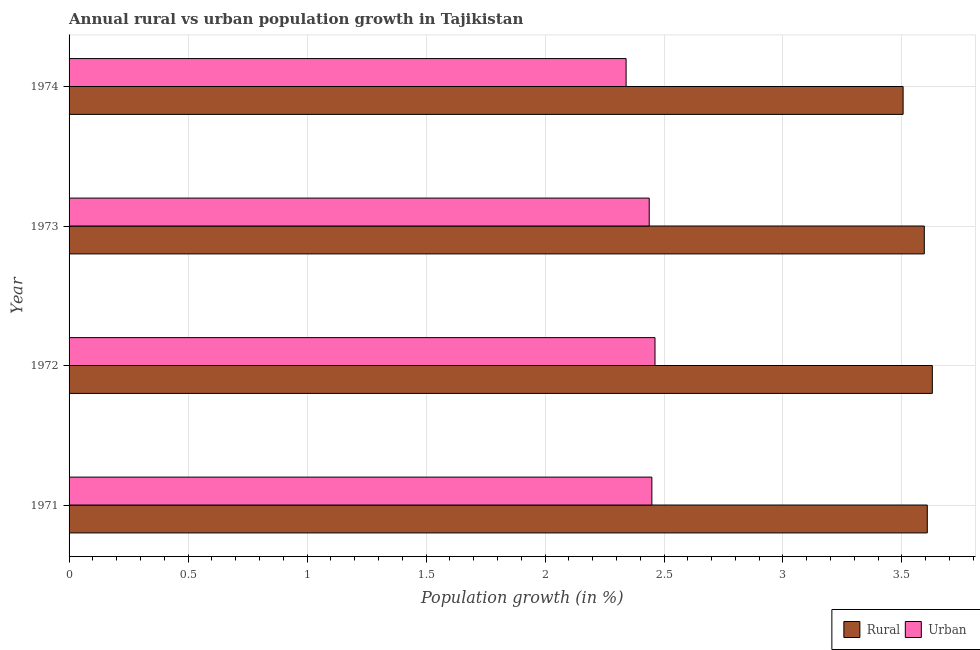How many groups of bars are there?
Offer a very short reply. 4. Are the number of bars per tick equal to the number of legend labels?
Your response must be concise. Yes. Are the number of bars on each tick of the Y-axis equal?
Keep it short and to the point. Yes. What is the label of the 2nd group of bars from the top?
Keep it short and to the point. 1973. In how many cases, is the number of bars for a given year not equal to the number of legend labels?
Your answer should be very brief. 0. What is the urban population growth in 1973?
Offer a terse response. 2.44. Across all years, what is the maximum rural population growth?
Make the answer very short. 3.63. Across all years, what is the minimum urban population growth?
Provide a succinct answer. 2.34. In which year was the rural population growth maximum?
Your answer should be compact. 1972. In which year was the rural population growth minimum?
Provide a short and direct response. 1974. What is the total rural population growth in the graph?
Your answer should be compact. 14.33. What is the difference between the urban population growth in 1972 and that in 1973?
Make the answer very short. 0.02. What is the difference between the rural population growth in 1974 and the urban population growth in 1972?
Provide a succinct answer. 1.04. What is the average rural population growth per year?
Your response must be concise. 3.58. In the year 1971, what is the difference between the urban population growth and rural population growth?
Ensure brevity in your answer.  -1.16. In how many years, is the rural population growth greater than 0.5 %?
Ensure brevity in your answer.  4. What is the ratio of the rural population growth in 1972 to that in 1974?
Provide a succinct answer. 1.03. Is the difference between the rural population growth in 1973 and 1974 greater than the difference between the urban population growth in 1973 and 1974?
Provide a succinct answer. No. What is the difference between the highest and the second highest rural population growth?
Your answer should be compact. 0.02. What is the difference between the highest and the lowest urban population growth?
Your answer should be very brief. 0.12. Is the sum of the rural population growth in 1972 and 1973 greater than the maximum urban population growth across all years?
Provide a short and direct response. Yes. What does the 1st bar from the top in 1971 represents?
Offer a terse response. Urban . What does the 1st bar from the bottom in 1972 represents?
Your response must be concise. Rural. How many bars are there?
Provide a short and direct response. 8. Are all the bars in the graph horizontal?
Your answer should be compact. Yes. What is the difference between two consecutive major ticks on the X-axis?
Offer a terse response. 0.5. Does the graph contain any zero values?
Offer a terse response. No. Does the graph contain grids?
Provide a short and direct response. Yes. Where does the legend appear in the graph?
Keep it short and to the point. Bottom right. What is the title of the graph?
Your answer should be compact. Annual rural vs urban population growth in Tajikistan. What is the label or title of the X-axis?
Your answer should be compact. Population growth (in %). What is the label or title of the Y-axis?
Provide a succinct answer. Year. What is the Population growth (in %) of Rural in 1971?
Your response must be concise. 3.61. What is the Population growth (in %) in Urban  in 1971?
Provide a short and direct response. 2.45. What is the Population growth (in %) of Rural in 1972?
Provide a succinct answer. 3.63. What is the Population growth (in %) of Urban  in 1972?
Offer a terse response. 2.46. What is the Population growth (in %) in Rural in 1973?
Ensure brevity in your answer.  3.59. What is the Population growth (in %) in Urban  in 1973?
Give a very brief answer. 2.44. What is the Population growth (in %) in Rural in 1974?
Your answer should be compact. 3.5. What is the Population growth (in %) in Urban  in 1974?
Offer a very short reply. 2.34. Across all years, what is the maximum Population growth (in %) in Rural?
Your response must be concise. 3.63. Across all years, what is the maximum Population growth (in %) in Urban ?
Keep it short and to the point. 2.46. Across all years, what is the minimum Population growth (in %) of Rural?
Give a very brief answer. 3.5. Across all years, what is the minimum Population growth (in %) in Urban ?
Provide a short and direct response. 2.34. What is the total Population growth (in %) in Rural in the graph?
Your response must be concise. 14.33. What is the total Population growth (in %) of Urban  in the graph?
Offer a terse response. 9.69. What is the difference between the Population growth (in %) of Rural in 1971 and that in 1972?
Ensure brevity in your answer.  -0.02. What is the difference between the Population growth (in %) in Urban  in 1971 and that in 1972?
Offer a very short reply. -0.01. What is the difference between the Population growth (in %) in Rural in 1971 and that in 1973?
Your response must be concise. 0.01. What is the difference between the Population growth (in %) in Urban  in 1971 and that in 1973?
Provide a short and direct response. 0.01. What is the difference between the Population growth (in %) of Rural in 1971 and that in 1974?
Ensure brevity in your answer.  0.1. What is the difference between the Population growth (in %) in Urban  in 1971 and that in 1974?
Your answer should be compact. 0.11. What is the difference between the Population growth (in %) of Rural in 1972 and that in 1973?
Your answer should be compact. 0.03. What is the difference between the Population growth (in %) of Urban  in 1972 and that in 1973?
Provide a succinct answer. 0.02. What is the difference between the Population growth (in %) in Rural in 1972 and that in 1974?
Make the answer very short. 0.12. What is the difference between the Population growth (in %) in Urban  in 1972 and that in 1974?
Make the answer very short. 0.12. What is the difference between the Population growth (in %) of Rural in 1973 and that in 1974?
Make the answer very short. 0.09. What is the difference between the Population growth (in %) in Urban  in 1973 and that in 1974?
Ensure brevity in your answer.  0.1. What is the difference between the Population growth (in %) of Rural in 1971 and the Population growth (in %) of Urban  in 1972?
Your response must be concise. 1.14. What is the difference between the Population growth (in %) of Rural in 1971 and the Population growth (in %) of Urban  in 1973?
Provide a succinct answer. 1.17. What is the difference between the Population growth (in %) in Rural in 1971 and the Population growth (in %) in Urban  in 1974?
Offer a terse response. 1.27. What is the difference between the Population growth (in %) in Rural in 1972 and the Population growth (in %) in Urban  in 1973?
Your answer should be compact. 1.19. What is the difference between the Population growth (in %) in Rural in 1972 and the Population growth (in %) in Urban  in 1974?
Your response must be concise. 1.29. What is the difference between the Population growth (in %) of Rural in 1973 and the Population growth (in %) of Urban  in 1974?
Offer a terse response. 1.25. What is the average Population growth (in %) in Rural per year?
Provide a succinct answer. 3.58. What is the average Population growth (in %) in Urban  per year?
Give a very brief answer. 2.42. In the year 1971, what is the difference between the Population growth (in %) of Rural and Population growth (in %) of Urban ?
Provide a succinct answer. 1.16. In the year 1972, what is the difference between the Population growth (in %) of Rural and Population growth (in %) of Urban ?
Your response must be concise. 1.17. In the year 1973, what is the difference between the Population growth (in %) of Rural and Population growth (in %) of Urban ?
Keep it short and to the point. 1.16. In the year 1974, what is the difference between the Population growth (in %) of Rural and Population growth (in %) of Urban ?
Provide a succinct answer. 1.16. What is the ratio of the Population growth (in %) of Rural in 1971 to that in 1972?
Give a very brief answer. 0.99. What is the ratio of the Population growth (in %) of Rural in 1971 to that in 1973?
Ensure brevity in your answer.  1. What is the ratio of the Population growth (in %) in Urban  in 1971 to that in 1973?
Your response must be concise. 1. What is the ratio of the Population growth (in %) of Rural in 1971 to that in 1974?
Offer a very short reply. 1.03. What is the ratio of the Population growth (in %) in Urban  in 1971 to that in 1974?
Provide a short and direct response. 1.05. What is the ratio of the Population growth (in %) in Rural in 1972 to that in 1973?
Offer a very short reply. 1.01. What is the ratio of the Population growth (in %) of Urban  in 1972 to that in 1973?
Give a very brief answer. 1.01. What is the ratio of the Population growth (in %) of Rural in 1972 to that in 1974?
Make the answer very short. 1.03. What is the ratio of the Population growth (in %) in Urban  in 1972 to that in 1974?
Offer a very short reply. 1.05. What is the ratio of the Population growth (in %) in Rural in 1973 to that in 1974?
Ensure brevity in your answer.  1.03. What is the ratio of the Population growth (in %) of Urban  in 1973 to that in 1974?
Provide a short and direct response. 1.04. What is the difference between the highest and the second highest Population growth (in %) of Rural?
Your answer should be very brief. 0.02. What is the difference between the highest and the second highest Population growth (in %) in Urban ?
Ensure brevity in your answer.  0.01. What is the difference between the highest and the lowest Population growth (in %) in Rural?
Offer a very short reply. 0.12. What is the difference between the highest and the lowest Population growth (in %) in Urban ?
Make the answer very short. 0.12. 